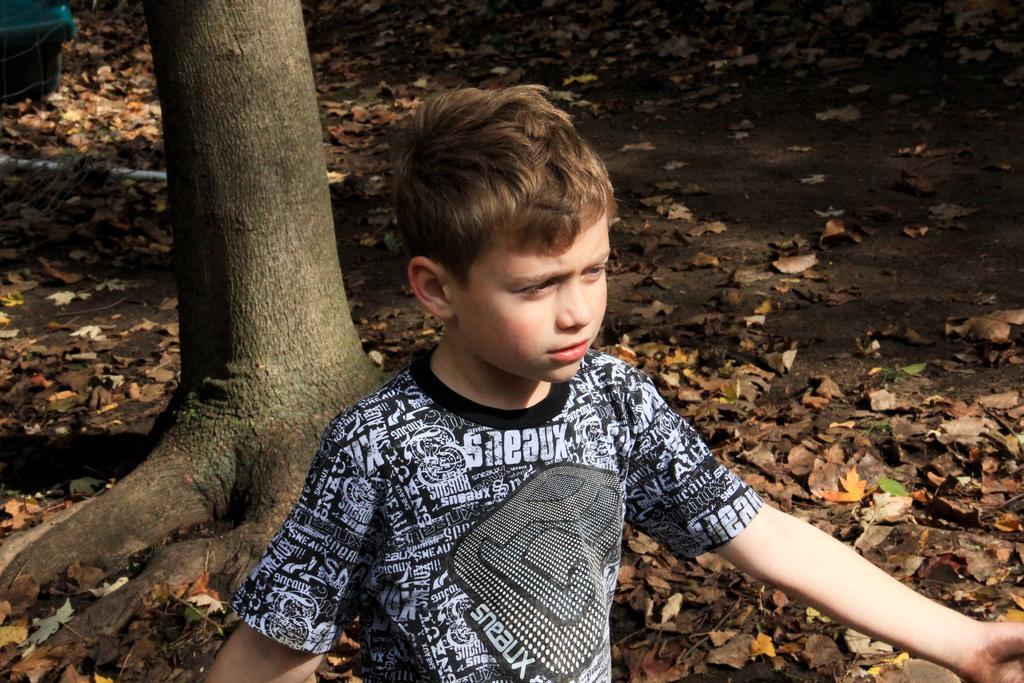Could you give a brief overview of what you see in this image? In this image, we can see some dry leaves on the ground. There is a kid at the bottom of the image wearing clothes. There is a stem in the middle of the image. 